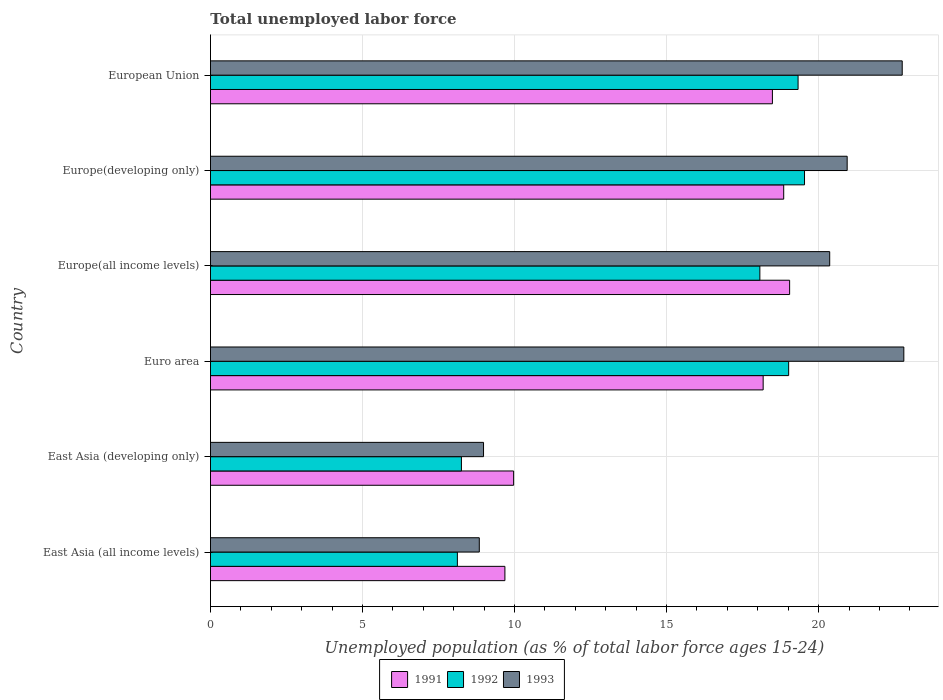How many different coloured bars are there?
Offer a terse response. 3. How many groups of bars are there?
Your response must be concise. 6. Are the number of bars per tick equal to the number of legend labels?
Give a very brief answer. Yes. What is the label of the 5th group of bars from the top?
Your answer should be compact. East Asia (developing only). In how many cases, is the number of bars for a given country not equal to the number of legend labels?
Provide a succinct answer. 0. What is the percentage of unemployed population in in 1992 in Euro area?
Your response must be concise. 19.01. Across all countries, what is the maximum percentage of unemployed population in in 1993?
Give a very brief answer. 22.8. Across all countries, what is the minimum percentage of unemployed population in in 1991?
Make the answer very short. 9.68. In which country was the percentage of unemployed population in in 1993 maximum?
Offer a very short reply. Euro area. In which country was the percentage of unemployed population in in 1993 minimum?
Offer a very short reply. East Asia (all income levels). What is the total percentage of unemployed population in in 1993 in the graph?
Give a very brief answer. 104.68. What is the difference between the percentage of unemployed population in in 1991 in East Asia (all income levels) and that in East Asia (developing only)?
Make the answer very short. -0.29. What is the difference between the percentage of unemployed population in in 1992 in Euro area and the percentage of unemployed population in in 1993 in Europe(all income levels)?
Your answer should be very brief. -1.35. What is the average percentage of unemployed population in in 1991 per country?
Provide a short and direct response. 15.7. What is the difference between the percentage of unemployed population in in 1992 and percentage of unemployed population in in 1991 in European Union?
Provide a short and direct response. 0.84. What is the ratio of the percentage of unemployed population in in 1991 in Europe(developing only) to that in European Union?
Your answer should be compact. 1.02. Is the percentage of unemployed population in in 1991 in Euro area less than that in Europe(all income levels)?
Your response must be concise. Yes. What is the difference between the highest and the second highest percentage of unemployed population in in 1992?
Your answer should be very brief. 0.21. What is the difference between the highest and the lowest percentage of unemployed population in in 1992?
Keep it short and to the point. 11.42. In how many countries, is the percentage of unemployed population in in 1991 greater than the average percentage of unemployed population in in 1991 taken over all countries?
Ensure brevity in your answer.  4. Is the sum of the percentage of unemployed population in in 1992 in East Asia (developing only) and European Union greater than the maximum percentage of unemployed population in in 1993 across all countries?
Ensure brevity in your answer.  Yes. What does the 1st bar from the bottom in East Asia (developing only) represents?
Offer a terse response. 1991. Is it the case that in every country, the sum of the percentage of unemployed population in in 1992 and percentage of unemployed population in in 1993 is greater than the percentage of unemployed population in in 1991?
Your answer should be compact. Yes. Are all the bars in the graph horizontal?
Provide a short and direct response. Yes. What is the difference between two consecutive major ticks on the X-axis?
Your response must be concise. 5. Are the values on the major ticks of X-axis written in scientific E-notation?
Keep it short and to the point. No. Does the graph contain any zero values?
Give a very brief answer. No. Where does the legend appear in the graph?
Offer a very short reply. Bottom center. How many legend labels are there?
Offer a terse response. 3. What is the title of the graph?
Offer a terse response. Total unemployed labor force. What is the label or title of the X-axis?
Give a very brief answer. Unemployed population (as % of total labor force ages 15-24). What is the label or title of the Y-axis?
Your answer should be very brief. Country. What is the Unemployed population (as % of total labor force ages 15-24) in 1991 in East Asia (all income levels)?
Ensure brevity in your answer.  9.68. What is the Unemployed population (as % of total labor force ages 15-24) of 1992 in East Asia (all income levels)?
Your answer should be very brief. 8.12. What is the Unemployed population (as % of total labor force ages 15-24) of 1993 in East Asia (all income levels)?
Offer a terse response. 8.84. What is the Unemployed population (as % of total labor force ages 15-24) in 1991 in East Asia (developing only)?
Offer a terse response. 9.97. What is the Unemployed population (as % of total labor force ages 15-24) of 1992 in East Asia (developing only)?
Your answer should be compact. 8.25. What is the Unemployed population (as % of total labor force ages 15-24) of 1993 in East Asia (developing only)?
Give a very brief answer. 8.98. What is the Unemployed population (as % of total labor force ages 15-24) of 1991 in Euro area?
Provide a short and direct response. 18.18. What is the Unemployed population (as % of total labor force ages 15-24) in 1992 in Euro area?
Your answer should be compact. 19.01. What is the Unemployed population (as % of total labor force ages 15-24) in 1993 in Euro area?
Provide a short and direct response. 22.8. What is the Unemployed population (as % of total labor force ages 15-24) of 1991 in Europe(all income levels)?
Ensure brevity in your answer.  19.05. What is the Unemployed population (as % of total labor force ages 15-24) of 1992 in Europe(all income levels)?
Provide a short and direct response. 18.07. What is the Unemployed population (as % of total labor force ages 15-24) in 1993 in Europe(all income levels)?
Your response must be concise. 20.36. What is the Unemployed population (as % of total labor force ages 15-24) in 1991 in Europe(developing only)?
Keep it short and to the point. 18.85. What is the Unemployed population (as % of total labor force ages 15-24) in 1992 in Europe(developing only)?
Ensure brevity in your answer.  19.54. What is the Unemployed population (as % of total labor force ages 15-24) of 1993 in Europe(developing only)?
Give a very brief answer. 20.94. What is the Unemployed population (as % of total labor force ages 15-24) in 1991 in European Union?
Keep it short and to the point. 18.48. What is the Unemployed population (as % of total labor force ages 15-24) in 1992 in European Union?
Ensure brevity in your answer.  19.32. What is the Unemployed population (as % of total labor force ages 15-24) of 1993 in European Union?
Keep it short and to the point. 22.75. Across all countries, what is the maximum Unemployed population (as % of total labor force ages 15-24) in 1991?
Make the answer very short. 19.05. Across all countries, what is the maximum Unemployed population (as % of total labor force ages 15-24) of 1992?
Offer a very short reply. 19.54. Across all countries, what is the maximum Unemployed population (as % of total labor force ages 15-24) of 1993?
Offer a terse response. 22.8. Across all countries, what is the minimum Unemployed population (as % of total labor force ages 15-24) in 1991?
Offer a terse response. 9.68. Across all countries, what is the minimum Unemployed population (as % of total labor force ages 15-24) of 1992?
Ensure brevity in your answer.  8.12. Across all countries, what is the minimum Unemployed population (as % of total labor force ages 15-24) in 1993?
Your answer should be very brief. 8.84. What is the total Unemployed population (as % of total labor force ages 15-24) of 1991 in the graph?
Make the answer very short. 94.21. What is the total Unemployed population (as % of total labor force ages 15-24) in 1992 in the graph?
Provide a short and direct response. 92.32. What is the total Unemployed population (as % of total labor force ages 15-24) in 1993 in the graph?
Make the answer very short. 104.68. What is the difference between the Unemployed population (as % of total labor force ages 15-24) in 1991 in East Asia (all income levels) and that in East Asia (developing only)?
Your answer should be compact. -0.29. What is the difference between the Unemployed population (as % of total labor force ages 15-24) of 1992 in East Asia (all income levels) and that in East Asia (developing only)?
Your answer should be very brief. -0.13. What is the difference between the Unemployed population (as % of total labor force ages 15-24) in 1993 in East Asia (all income levels) and that in East Asia (developing only)?
Offer a very short reply. -0.14. What is the difference between the Unemployed population (as % of total labor force ages 15-24) in 1991 in East Asia (all income levels) and that in Euro area?
Your response must be concise. -8.49. What is the difference between the Unemployed population (as % of total labor force ages 15-24) in 1992 in East Asia (all income levels) and that in Euro area?
Keep it short and to the point. -10.9. What is the difference between the Unemployed population (as % of total labor force ages 15-24) of 1993 in East Asia (all income levels) and that in Euro area?
Provide a short and direct response. -13.96. What is the difference between the Unemployed population (as % of total labor force ages 15-24) of 1991 in East Asia (all income levels) and that in Europe(all income levels)?
Ensure brevity in your answer.  -9.36. What is the difference between the Unemployed population (as % of total labor force ages 15-24) of 1992 in East Asia (all income levels) and that in Europe(all income levels)?
Ensure brevity in your answer.  -9.95. What is the difference between the Unemployed population (as % of total labor force ages 15-24) of 1993 in East Asia (all income levels) and that in Europe(all income levels)?
Ensure brevity in your answer.  -11.52. What is the difference between the Unemployed population (as % of total labor force ages 15-24) of 1991 in East Asia (all income levels) and that in Europe(developing only)?
Your response must be concise. -9.17. What is the difference between the Unemployed population (as % of total labor force ages 15-24) in 1992 in East Asia (all income levels) and that in Europe(developing only)?
Provide a succinct answer. -11.42. What is the difference between the Unemployed population (as % of total labor force ages 15-24) of 1993 in East Asia (all income levels) and that in Europe(developing only)?
Offer a very short reply. -12.1. What is the difference between the Unemployed population (as % of total labor force ages 15-24) in 1991 in East Asia (all income levels) and that in European Union?
Make the answer very short. -8.8. What is the difference between the Unemployed population (as % of total labor force ages 15-24) in 1992 in East Asia (all income levels) and that in European Union?
Your answer should be compact. -11.2. What is the difference between the Unemployed population (as % of total labor force ages 15-24) in 1993 in East Asia (all income levels) and that in European Union?
Your response must be concise. -13.91. What is the difference between the Unemployed population (as % of total labor force ages 15-24) in 1991 in East Asia (developing only) and that in Euro area?
Make the answer very short. -8.21. What is the difference between the Unemployed population (as % of total labor force ages 15-24) of 1992 in East Asia (developing only) and that in Euro area?
Ensure brevity in your answer.  -10.76. What is the difference between the Unemployed population (as % of total labor force ages 15-24) in 1993 in East Asia (developing only) and that in Euro area?
Make the answer very short. -13.82. What is the difference between the Unemployed population (as % of total labor force ages 15-24) in 1991 in East Asia (developing only) and that in Europe(all income levels)?
Provide a succinct answer. -9.08. What is the difference between the Unemployed population (as % of total labor force ages 15-24) of 1992 in East Asia (developing only) and that in Europe(all income levels)?
Provide a short and direct response. -9.81. What is the difference between the Unemployed population (as % of total labor force ages 15-24) in 1993 in East Asia (developing only) and that in Europe(all income levels)?
Make the answer very short. -11.38. What is the difference between the Unemployed population (as % of total labor force ages 15-24) of 1991 in East Asia (developing only) and that in Europe(developing only)?
Provide a succinct answer. -8.88. What is the difference between the Unemployed population (as % of total labor force ages 15-24) in 1992 in East Asia (developing only) and that in Europe(developing only)?
Offer a terse response. -11.28. What is the difference between the Unemployed population (as % of total labor force ages 15-24) of 1993 in East Asia (developing only) and that in Europe(developing only)?
Your response must be concise. -11.96. What is the difference between the Unemployed population (as % of total labor force ages 15-24) of 1991 in East Asia (developing only) and that in European Union?
Provide a short and direct response. -8.51. What is the difference between the Unemployed population (as % of total labor force ages 15-24) in 1992 in East Asia (developing only) and that in European Union?
Offer a terse response. -11.07. What is the difference between the Unemployed population (as % of total labor force ages 15-24) in 1993 in East Asia (developing only) and that in European Union?
Your answer should be compact. -13.77. What is the difference between the Unemployed population (as % of total labor force ages 15-24) of 1991 in Euro area and that in Europe(all income levels)?
Provide a succinct answer. -0.87. What is the difference between the Unemployed population (as % of total labor force ages 15-24) of 1992 in Euro area and that in Europe(all income levels)?
Make the answer very short. 0.95. What is the difference between the Unemployed population (as % of total labor force ages 15-24) in 1993 in Euro area and that in Europe(all income levels)?
Make the answer very short. 2.44. What is the difference between the Unemployed population (as % of total labor force ages 15-24) in 1991 in Euro area and that in Europe(developing only)?
Ensure brevity in your answer.  -0.68. What is the difference between the Unemployed population (as % of total labor force ages 15-24) of 1992 in Euro area and that in Europe(developing only)?
Make the answer very short. -0.52. What is the difference between the Unemployed population (as % of total labor force ages 15-24) of 1993 in Euro area and that in Europe(developing only)?
Your answer should be very brief. 1.86. What is the difference between the Unemployed population (as % of total labor force ages 15-24) of 1991 in Euro area and that in European Union?
Offer a very short reply. -0.3. What is the difference between the Unemployed population (as % of total labor force ages 15-24) of 1992 in Euro area and that in European Union?
Give a very brief answer. -0.31. What is the difference between the Unemployed population (as % of total labor force ages 15-24) of 1993 in Euro area and that in European Union?
Your response must be concise. 0.05. What is the difference between the Unemployed population (as % of total labor force ages 15-24) in 1991 in Europe(all income levels) and that in Europe(developing only)?
Keep it short and to the point. 0.19. What is the difference between the Unemployed population (as % of total labor force ages 15-24) of 1992 in Europe(all income levels) and that in Europe(developing only)?
Your answer should be compact. -1.47. What is the difference between the Unemployed population (as % of total labor force ages 15-24) of 1993 in Europe(all income levels) and that in Europe(developing only)?
Your answer should be compact. -0.57. What is the difference between the Unemployed population (as % of total labor force ages 15-24) in 1991 in Europe(all income levels) and that in European Union?
Ensure brevity in your answer.  0.57. What is the difference between the Unemployed population (as % of total labor force ages 15-24) of 1992 in Europe(all income levels) and that in European Union?
Offer a terse response. -1.26. What is the difference between the Unemployed population (as % of total labor force ages 15-24) in 1993 in Europe(all income levels) and that in European Union?
Make the answer very short. -2.38. What is the difference between the Unemployed population (as % of total labor force ages 15-24) in 1991 in Europe(developing only) and that in European Union?
Ensure brevity in your answer.  0.37. What is the difference between the Unemployed population (as % of total labor force ages 15-24) in 1992 in Europe(developing only) and that in European Union?
Offer a very short reply. 0.21. What is the difference between the Unemployed population (as % of total labor force ages 15-24) of 1993 in Europe(developing only) and that in European Union?
Make the answer very short. -1.81. What is the difference between the Unemployed population (as % of total labor force ages 15-24) of 1991 in East Asia (all income levels) and the Unemployed population (as % of total labor force ages 15-24) of 1992 in East Asia (developing only)?
Offer a very short reply. 1.43. What is the difference between the Unemployed population (as % of total labor force ages 15-24) of 1991 in East Asia (all income levels) and the Unemployed population (as % of total labor force ages 15-24) of 1993 in East Asia (developing only)?
Keep it short and to the point. 0.7. What is the difference between the Unemployed population (as % of total labor force ages 15-24) of 1992 in East Asia (all income levels) and the Unemployed population (as % of total labor force ages 15-24) of 1993 in East Asia (developing only)?
Provide a short and direct response. -0.86. What is the difference between the Unemployed population (as % of total labor force ages 15-24) in 1991 in East Asia (all income levels) and the Unemployed population (as % of total labor force ages 15-24) in 1992 in Euro area?
Ensure brevity in your answer.  -9.33. What is the difference between the Unemployed population (as % of total labor force ages 15-24) of 1991 in East Asia (all income levels) and the Unemployed population (as % of total labor force ages 15-24) of 1993 in Euro area?
Offer a terse response. -13.12. What is the difference between the Unemployed population (as % of total labor force ages 15-24) in 1992 in East Asia (all income levels) and the Unemployed population (as % of total labor force ages 15-24) in 1993 in Euro area?
Give a very brief answer. -14.68. What is the difference between the Unemployed population (as % of total labor force ages 15-24) of 1991 in East Asia (all income levels) and the Unemployed population (as % of total labor force ages 15-24) of 1992 in Europe(all income levels)?
Give a very brief answer. -8.38. What is the difference between the Unemployed population (as % of total labor force ages 15-24) of 1991 in East Asia (all income levels) and the Unemployed population (as % of total labor force ages 15-24) of 1993 in Europe(all income levels)?
Offer a very short reply. -10.68. What is the difference between the Unemployed population (as % of total labor force ages 15-24) in 1992 in East Asia (all income levels) and the Unemployed population (as % of total labor force ages 15-24) in 1993 in Europe(all income levels)?
Your response must be concise. -12.24. What is the difference between the Unemployed population (as % of total labor force ages 15-24) in 1991 in East Asia (all income levels) and the Unemployed population (as % of total labor force ages 15-24) in 1992 in Europe(developing only)?
Keep it short and to the point. -9.85. What is the difference between the Unemployed population (as % of total labor force ages 15-24) of 1991 in East Asia (all income levels) and the Unemployed population (as % of total labor force ages 15-24) of 1993 in Europe(developing only)?
Keep it short and to the point. -11.26. What is the difference between the Unemployed population (as % of total labor force ages 15-24) in 1992 in East Asia (all income levels) and the Unemployed population (as % of total labor force ages 15-24) in 1993 in Europe(developing only)?
Ensure brevity in your answer.  -12.82. What is the difference between the Unemployed population (as % of total labor force ages 15-24) of 1991 in East Asia (all income levels) and the Unemployed population (as % of total labor force ages 15-24) of 1992 in European Union?
Ensure brevity in your answer.  -9.64. What is the difference between the Unemployed population (as % of total labor force ages 15-24) of 1991 in East Asia (all income levels) and the Unemployed population (as % of total labor force ages 15-24) of 1993 in European Union?
Ensure brevity in your answer.  -13.07. What is the difference between the Unemployed population (as % of total labor force ages 15-24) of 1992 in East Asia (all income levels) and the Unemployed population (as % of total labor force ages 15-24) of 1993 in European Union?
Keep it short and to the point. -14.63. What is the difference between the Unemployed population (as % of total labor force ages 15-24) in 1991 in East Asia (developing only) and the Unemployed population (as % of total labor force ages 15-24) in 1992 in Euro area?
Make the answer very short. -9.05. What is the difference between the Unemployed population (as % of total labor force ages 15-24) in 1991 in East Asia (developing only) and the Unemployed population (as % of total labor force ages 15-24) in 1993 in Euro area?
Give a very brief answer. -12.83. What is the difference between the Unemployed population (as % of total labor force ages 15-24) of 1992 in East Asia (developing only) and the Unemployed population (as % of total labor force ages 15-24) of 1993 in Euro area?
Ensure brevity in your answer.  -14.55. What is the difference between the Unemployed population (as % of total labor force ages 15-24) in 1991 in East Asia (developing only) and the Unemployed population (as % of total labor force ages 15-24) in 1992 in Europe(all income levels)?
Your answer should be compact. -8.1. What is the difference between the Unemployed population (as % of total labor force ages 15-24) in 1991 in East Asia (developing only) and the Unemployed population (as % of total labor force ages 15-24) in 1993 in Europe(all income levels)?
Ensure brevity in your answer.  -10.39. What is the difference between the Unemployed population (as % of total labor force ages 15-24) of 1992 in East Asia (developing only) and the Unemployed population (as % of total labor force ages 15-24) of 1993 in Europe(all income levels)?
Your answer should be compact. -12.11. What is the difference between the Unemployed population (as % of total labor force ages 15-24) in 1991 in East Asia (developing only) and the Unemployed population (as % of total labor force ages 15-24) in 1992 in Europe(developing only)?
Ensure brevity in your answer.  -9.57. What is the difference between the Unemployed population (as % of total labor force ages 15-24) of 1991 in East Asia (developing only) and the Unemployed population (as % of total labor force ages 15-24) of 1993 in Europe(developing only)?
Provide a short and direct response. -10.97. What is the difference between the Unemployed population (as % of total labor force ages 15-24) of 1992 in East Asia (developing only) and the Unemployed population (as % of total labor force ages 15-24) of 1993 in Europe(developing only)?
Keep it short and to the point. -12.69. What is the difference between the Unemployed population (as % of total labor force ages 15-24) in 1991 in East Asia (developing only) and the Unemployed population (as % of total labor force ages 15-24) in 1992 in European Union?
Offer a terse response. -9.35. What is the difference between the Unemployed population (as % of total labor force ages 15-24) in 1991 in East Asia (developing only) and the Unemployed population (as % of total labor force ages 15-24) in 1993 in European Union?
Your answer should be very brief. -12.78. What is the difference between the Unemployed population (as % of total labor force ages 15-24) of 1992 in East Asia (developing only) and the Unemployed population (as % of total labor force ages 15-24) of 1993 in European Union?
Make the answer very short. -14.5. What is the difference between the Unemployed population (as % of total labor force ages 15-24) in 1991 in Euro area and the Unemployed population (as % of total labor force ages 15-24) in 1992 in Europe(all income levels)?
Your answer should be very brief. 0.11. What is the difference between the Unemployed population (as % of total labor force ages 15-24) in 1991 in Euro area and the Unemployed population (as % of total labor force ages 15-24) in 1993 in Europe(all income levels)?
Ensure brevity in your answer.  -2.19. What is the difference between the Unemployed population (as % of total labor force ages 15-24) of 1992 in Euro area and the Unemployed population (as % of total labor force ages 15-24) of 1993 in Europe(all income levels)?
Your answer should be very brief. -1.35. What is the difference between the Unemployed population (as % of total labor force ages 15-24) of 1991 in Euro area and the Unemployed population (as % of total labor force ages 15-24) of 1992 in Europe(developing only)?
Offer a terse response. -1.36. What is the difference between the Unemployed population (as % of total labor force ages 15-24) in 1991 in Euro area and the Unemployed population (as % of total labor force ages 15-24) in 1993 in Europe(developing only)?
Your response must be concise. -2.76. What is the difference between the Unemployed population (as % of total labor force ages 15-24) in 1992 in Euro area and the Unemployed population (as % of total labor force ages 15-24) in 1993 in Europe(developing only)?
Make the answer very short. -1.92. What is the difference between the Unemployed population (as % of total labor force ages 15-24) in 1991 in Euro area and the Unemployed population (as % of total labor force ages 15-24) in 1992 in European Union?
Your answer should be compact. -1.15. What is the difference between the Unemployed population (as % of total labor force ages 15-24) in 1991 in Euro area and the Unemployed population (as % of total labor force ages 15-24) in 1993 in European Union?
Your answer should be very brief. -4.57. What is the difference between the Unemployed population (as % of total labor force ages 15-24) of 1992 in Euro area and the Unemployed population (as % of total labor force ages 15-24) of 1993 in European Union?
Offer a terse response. -3.73. What is the difference between the Unemployed population (as % of total labor force ages 15-24) of 1991 in Europe(all income levels) and the Unemployed population (as % of total labor force ages 15-24) of 1992 in Europe(developing only)?
Ensure brevity in your answer.  -0.49. What is the difference between the Unemployed population (as % of total labor force ages 15-24) in 1991 in Europe(all income levels) and the Unemployed population (as % of total labor force ages 15-24) in 1993 in Europe(developing only)?
Your answer should be very brief. -1.89. What is the difference between the Unemployed population (as % of total labor force ages 15-24) in 1992 in Europe(all income levels) and the Unemployed population (as % of total labor force ages 15-24) in 1993 in Europe(developing only)?
Give a very brief answer. -2.87. What is the difference between the Unemployed population (as % of total labor force ages 15-24) in 1991 in Europe(all income levels) and the Unemployed population (as % of total labor force ages 15-24) in 1992 in European Union?
Provide a short and direct response. -0.28. What is the difference between the Unemployed population (as % of total labor force ages 15-24) in 1991 in Europe(all income levels) and the Unemployed population (as % of total labor force ages 15-24) in 1993 in European Union?
Ensure brevity in your answer.  -3.7. What is the difference between the Unemployed population (as % of total labor force ages 15-24) of 1992 in Europe(all income levels) and the Unemployed population (as % of total labor force ages 15-24) of 1993 in European Union?
Your response must be concise. -4.68. What is the difference between the Unemployed population (as % of total labor force ages 15-24) in 1991 in Europe(developing only) and the Unemployed population (as % of total labor force ages 15-24) in 1992 in European Union?
Your answer should be compact. -0.47. What is the difference between the Unemployed population (as % of total labor force ages 15-24) of 1991 in Europe(developing only) and the Unemployed population (as % of total labor force ages 15-24) of 1993 in European Union?
Your answer should be compact. -3.9. What is the difference between the Unemployed population (as % of total labor force ages 15-24) in 1992 in Europe(developing only) and the Unemployed population (as % of total labor force ages 15-24) in 1993 in European Union?
Provide a succinct answer. -3.21. What is the average Unemployed population (as % of total labor force ages 15-24) of 1991 per country?
Your response must be concise. 15.7. What is the average Unemployed population (as % of total labor force ages 15-24) of 1992 per country?
Make the answer very short. 15.39. What is the average Unemployed population (as % of total labor force ages 15-24) of 1993 per country?
Provide a short and direct response. 17.45. What is the difference between the Unemployed population (as % of total labor force ages 15-24) in 1991 and Unemployed population (as % of total labor force ages 15-24) in 1992 in East Asia (all income levels)?
Provide a short and direct response. 1.56. What is the difference between the Unemployed population (as % of total labor force ages 15-24) of 1991 and Unemployed population (as % of total labor force ages 15-24) of 1993 in East Asia (all income levels)?
Offer a very short reply. 0.84. What is the difference between the Unemployed population (as % of total labor force ages 15-24) in 1992 and Unemployed population (as % of total labor force ages 15-24) in 1993 in East Asia (all income levels)?
Offer a terse response. -0.72. What is the difference between the Unemployed population (as % of total labor force ages 15-24) of 1991 and Unemployed population (as % of total labor force ages 15-24) of 1992 in East Asia (developing only)?
Provide a succinct answer. 1.72. What is the difference between the Unemployed population (as % of total labor force ages 15-24) of 1992 and Unemployed population (as % of total labor force ages 15-24) of 1993 in East Asia (developing only)?
Provide a short and direct response. -0.73. What is the difference between the Unemployed population (as % of total labor force ages 15-24) in 1991 and Unemployed population (as % of total labor force ages 15-24) in 1992 in Euro area?
Your response must be concise. -0.84. What is the difference between the Unemployed population (as % of total labor force ages 15-24) of 1991 and Unemployed population (as % of total labor force ages 15-24) of 1993 in Euro area?
Give a very brief answer. -4.63. What is the difference between the Unemployed population (as % of total labor force ages 15-24) of 1992 and Unemployed population (as % of total labor force ages 15-24) of 1993 in Euro area?
Offer a very short reply. -3.79. What is the difference between the Unemployed population (as % of total labor force ages 15-24) of 1991 and Unemployed population (as % of total labor force ages 15-24) of 1993 in Europe(all income levels)?
Ensure brevity in your answer.  -1.32. What is the difference between the Unemployed population (as % of total labor force ages 15-24) in 1992 and Unemployed population (as % of total labor force ages 15-24) in 1993 in Europe(all income levels)?
Ensure brevity in your answer.  -2.3. What is the difference between the Unemployed population (as % of total labor force ages 15-24) of 1991 and Unemployed population (as % of total labor force ages 15-24) of 1992 in Europe(developing only)?
Offer a very short reply. -0.68. What is the difference between the Unemployed population (as % of total labor force ages 15-24) in 1991 and Unemployed population (as % of total labor force ages 15-24) in 1993 in Europe(developing only)?
Keep it short and to the point. -2.09. What is the difference between the Unemployed population (as % of total labor force ages 15-24) in 1992 and Unemployed population (as % of total labor force ages 15-24) in 1993 in Europe(developing only)?
Your response must be concise. -1.4. What is the difference between the Unemployed population (as % of total labor force ages 15-24) of 1991 and Unemployed population (as % of total labor force ages 15-24) of 1992 in European Union?
Offer a terse response. -0.84. What is the difference between the Unemployed population (as % of total labor force ages 15-24) of 1991 and Unemployed population (as % of total labor force ages 15-24) of 1993 in European Union?
Provide a short and direct response. -4.27. What is the difference between the Unemployed population (as % of total labor force ages 15-24) in 1992 and Unemployed population (as % of total labor force ages 15-24) in 1993 in European Union?
Keep it short and to the point. -3.43. What is the ratio of the Unemployed population (as % of total labor force ages 15-24) in 1991 in East Asia (all income levels) to that in East Asia (developing only)?
Your response must be concise. 0.97. What is the ratio of the Unemployed population (as % of total labor force ages 15-24) in 1992 in East Asia (all income levels) to that in East Asia (developing only)?
Provide a short and direct response. 0.98. What is the ratio of the Unemployed population (as % of total labor force ages 15-24) of 1993 in East Asia (all income levels) to that in East Asia (developing only)?
Provide a short and direct response. 0.98. What is the ratio of the Unemployed population (as % of total labor force ages 15-24) of 1991 in East Asia (all income levels) to that in Euro area?
Keep it short and to the point. 0.53. What is the ratio of the Unemployed population (as % of total labor force ages 15-24) in 1992 in East Asia (all income levels) to that in Euro area?
Provide a succinct answer. 0.43. What is the ratio of the Unemployed population (as % of total labor force ages 15-24) of 1993 in East Asia (all income levels) to that in Euro area?
Your answer should be compact. 0.39. What is the ratio of the Unemployed population (as % of total labor force ages 15-24) in 1991 in East Asia (all income levels) to that in Europe(all income levels)?
Provide a short and direct response. 0.51. What is the ratio of the Unemployed population (as % of total labor force ages 15-24) of 1992 in East Asia (all income levels) to that in Europe(all income levels)?
Your answer should be very brief. 0.45. What is the ratio of the Unemployed population (as % of total labor force ages 15-24) in 1993 in East Asia (all income levels) to that in Europe(all income levels)?
Offer a terse response. 0.43. What is the ratio of the Unemployed population (as % of total labor force ages 15-24) of 1991 in East Asia (all income levels) to that in Europe(developing only)?
Offer a very short reply. 0.51. What is the ratio of the Unemployed population (as % of total labor force ages 15-24) of 1992 in East Asia (all income levels) to that in Europe(developing only)?
Provide a short and direct response. 0.42. What is the ratio of the Unemployed population (as % of total labor force ages 15-24) in 1993 in East Asia (all income levels) to that in Europe(developing only)?
Your response must be concise. 0.42. What is the ratio of the Unemployed population (as % of total labor force ages 15-24) in 1991 in East Asia (all income levels) to that in European Union?
Offer a very short reply. 0.52. What is the ratio of the Unemployed population (as % of total labor force ages 15-24) in 1992 in East Asia (all income levels) to that in European Union?
Your answer should be very brief. 0.42. What is the ratio of the Unemployed population (as % of total labor force ages 15-24) of 1993 in East Asia (all income levels) to that in European Union?
Provide a short and direct response. 0.39. What is the ratio of the Unemployed population (as % of total labor force ages 15-24) in 1991 in East Asia (developing only) to that in Euro area?
Your answer should be compact. 0.55. What is the ratio of the Unemployed population (as % of total labor force ages 15-24) of 1992 in East Asia (developing only) to that in Euro area?
Give a very brief answer. 0.43. What is the ratio of the Unemployed population (as % of total labor force ages 15-24) in 1993 in East Asia (developing only) to that in Euro area?
Your response must be concise. 0.39. What is the ratio of the Unemployed population (as % of total labor force ages 15-24) of 1991 in East Asia (developing only) to that in Europe(all income levels)?
Offer a terse response. 0.52. What is the ratio of the Unemployed population (as % of total labor force ages 15-24) in 1992 in East Asia (developing only) to that in Europe(all income levels)?
Keep it short and to the point. 0.46. What is the ratio of the Unemployed population (as % of total labor force ages 15-24) of 1993 in East Asia (developing only) to that in Europe(all income levels)?
Ensure brevity in your answer.  0.44. What is the ratio of the Unemployed population (as % of total labor force ages 15-24) of 1991 in East Asia (developing only) to that in Europe(developing only)?
Provide a succinct answer. 0.53. What is the ratio of the Unemployed population (as % of total labor force ages 15-24) of 1992 in East Asia (developing only) to that in Europe(developing only)?
Ensure brevity in your answer.  0.42. What is the ratio of the Unemployed population (as % of total labor force ages 15-24) in 1993 in East Asia (developing only) to that in Europe(developing only)?
Ensure brevity in your answer.  0.43. What is the ratio of the Unemployed population (as % of total labor force ages 15-24) of 1991 in East Asia (developing only) to that in European Union?
Your answer should be compact. 0.54. What is the ratio of the Unemployed population (as % of total labor force ages 15-24) in 1992 in East Asia (developing only) to that in European Union?
Keep it short and to the point. 0.43. What is the ratio of the Unemployed population (as % of total labor force ages 15-24) of 1993 in East Asia (developing only) to that in European Union?
Your answer should be compact. 0.39. What is the ratio of the Unemployed population (as % of total labor force ages 15-24) in 1991 in Euro area to that in Europe(all income levels)?
Keep it short and to the point. 0.95. What is the ratio of the Unemployed population (as % of total labor force ages 15-24) in 1992 in Euro area to that in Europe(all income levels)?
Give a very brief answer. 1.05. What is the ratio of the Unemployed population (as % of total labor force ages 15-24) of 1993 in Euro area to that in Europe(all income levels)?
Offer a terse response. 1.12. What is the ratio of the Unemployed population (as % of total labor force ages 15-24) of 1991 in Euro area to that in Europe(developing only)?
Make the answer very short. 0.96. What is the ratio of the Unemployed population (as % of total labor force ages 15-24) in 1992 in Euro area to that in Europe(developing only)?
Offer a terse response. 0.97. What is the ratio of the Unemployed population (as % of total labor force ages 15-24) of 1993 in Euro area to that in Europe(developing only)?
Ensure brevity in your answer.  1.09. What is the ratio of the Unemployed population (as % of total labor force ages 15-24) of 1991 in Euro area to that in European Union?
Offer a terse response. 0.98. What is the ratio of the Unemployed population (as % of total labor force ages 15-24) of 1992 in Euro area to that in European Union?
Your response must be concise. 0.98. What is the ratio of the Unemployed population (as % of total labor force ages 15-24) of 1993 in Euro area to that in European Union?
Your answer should be very brief. 1. What is the ratio of the Unemployed population (as % of total labor force ages 15-24) of 1991 in Europe(all income levels) to that in Europe(developing only)?
Offer a terse response. 1.01. What is the ratio of the Unemployed population (as % of total labor force ages 15-24) of 1992 in Europe(all income levels) to that in Europe(developing only)?
Your response must be concise. 0.92. What is the ratio of the Unemployed population (as % of total labor force ages 15-24) in 1993 in Europe(all income levels) to that in Europe(developing only)?
Your answer should be very brief. 0.97. What is the ratio of the Unemployed population (as % of total labor force ages 15-24) of 1991 in Europe(all income levels) to that in European Union?
Make the answer very short. 1.03. What is the ratio of the Unemployed population (as % of total labor force ages 15-24) of 1992 in Europe(all income levels) to that in European Union?
Offer a terse response. 0.94. What is the ratio of the Unemployed population (as % of total labor force ages 15-24) in 1993 in Europe(all income levels) to that in European Union?
Provide a short and direct response. 0.9. What is the ratio of the Unemployed population (as % of total labor force ages 15-24) of 1991 in Europe(developing only) to that in European Union?
Your answer should be very brief. 1.02. What is the ratio of the Unemployed population (as % of total labor force ages 15-24) in 1993 in Europe(developing only) to that in European Union?
Provide a short and direct response. 0.92. What is the difference between the highest and the second highest Unemployed population (as % of total labor force ages 15-24) in 1991?
Your response must be concise. 0.19. What is the difference between the highest and the second highest Unemployed population (as % of total labor force ages 15-24) in 1992?
Provide a succinct answer. 0.21. What is the difference between the highest and the second highest Unemployed population (as % of total labor force ages 15-24) of 1993?
Your response must be concise. 0.05. What is the difference between the highest and the lowest Unemployed population (as % of total labor force ages 15-24) of 1991?
Your answer should be very brief. 9.36. What is the difference between the highest and the lowest Unemployed population (as % of total labor force ages 15-24) of 1992?
Your answer should be very brief. 11.42. What is the difference between the highest and the lowest Unemployed population (as % of total labor force ages 15-24) in 1993?
Ensure brevity in your answer.  13.96. 